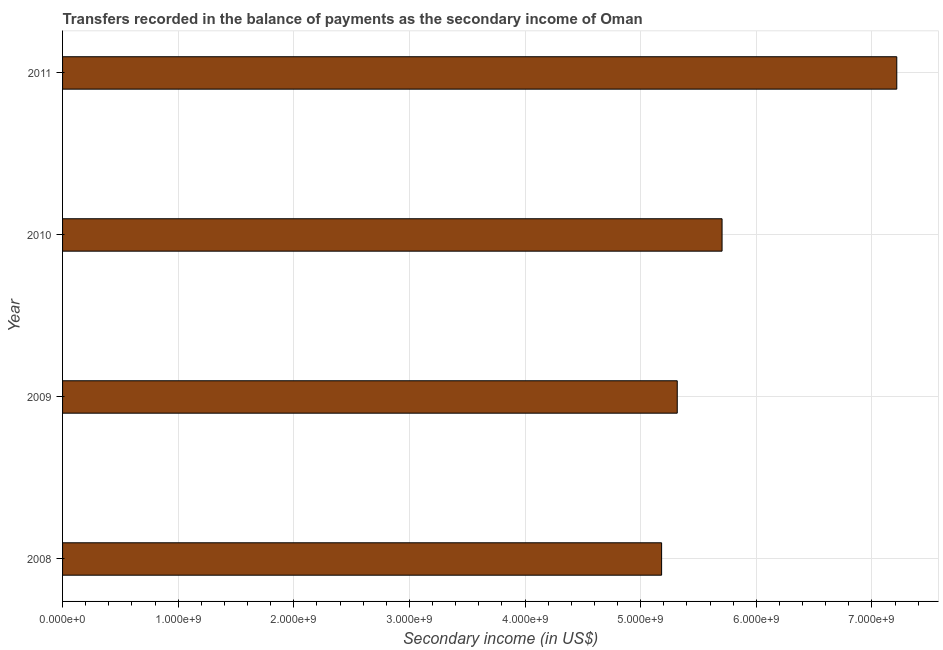Does the graph contain any zero values?
Your response must be concise. No. Does the graph contain grids?
Give a very brief answer. Yes. What is the title of the graph?
Your response must be concise. Transfers recorded in the balance of payments as the secondary income of Oman. What is the label or title of the X-axis?
Your response must be concise. Secondary income (in US$). What is the label or title of the Y-axis?
Offer a very short reply. Year. What is the amount of secondary income in 2010?
Your answer should be very brief. 5.70e+09. Across all years, what is the maximum amount of secondary income?
Provide a short and direct response. 7.21e+09. Across all years, what is the minimum amount of secondary income?
Ensure brevity in your answer.  5.18e+09. What is the sum of the amount of secondary income?
Your answer should be compact. 2.34e+1. What is the difference between the amount of secondary income in 2009 and 2011?
Offer a terse response. -1.90e+09. What is the average amount of secondary income per year?
Offer a terse response. 5.85e+09. What is the median amount of secondary income?
Your answer should be very brief. 5.51e+09. In how many years, is the amount of secondary income greater than 4800000000 US$?
Your response must be concise. 4. What is the ratio of the amount of secondary income in 2009 to that in 2010?
Ensure brevity in your answer.  0.93. What is the difference between the highest and the second highest amount of secondary income?
Your answer should be very brief. 1.51e+09. Is the sum of the amount of secondary income in 2009 and 2010 greater than the maximum amount of secondary income across all years?
Provide a short and direct response. Yes. What is the difference between the highest and the lowest amount of secondary income?
Offer a terse response. 2.03e+09. In how many years, is the amount of secondary income greater than the average amount of secondary income taken over all years?
Ensure brevity in your answer.  1. How many bars are there?
Your answer should be very brief. 4. How many years are there in the graph?
Your answer should be very brief. 4. Are the values on the major ticks of X-axis written in scientific E-notation?
Provide a succinct answer. Yes. What is the Secondary income (in US$) in 2008?
Your answer should be compact. 5.18e+09. What is the Secondary income (in US$) in 2009?
Offer a terse response. 5.32e+09. What is the Secondary income (in US$) of 2010?
Your answer should be very brief. 5.70e+09. What is the Secondary income (in US$) of 2011?
Make the answer very short. 7.21e+09. What is the difference between the Secondary income (in US$) in 2008 and 2009?
Offer a very short reply. -1.35e+08. What is the difference between the Secondary income (in US$) in 2008 and 2010?
Keep it short and to the point. -5.23e+08. What is the difference between the Secondary income (in US$) in 2008 and 2011?
Offer a terse response. -2.03e+09. What is the difference between the Secondary income (in US$) in 2009 and 2010?
Your answer should be very brief. -3.88e+08. What is the difference between the Secondary income (in US$) in 2009 and 2011?
Give a very brief answer. -1.90e+09. What is the difference between the Secondary income (in US$) in 2010 and 2011?
Your response must be concise. -1.51e+09. What is the ratio of the Secondary income (in US$) in 2008 to that in 2010?
Your answer should be compact. 0.91. What is the ratio of the Secondary income (in US$) in 2008 to that in 2011?
Make the answer very short. 0.72. What is the ratio of the Secondary income (in US$) in 2009 to that in 2010?
Offer a very short reply. 0.93. What is the ratio of the Secondary income (in US$) in 2009 to that in 2011?
Keep it short and to the point. 0.74. What is the ratio of the Secondary income (in US$) in 2010 to that in 2011?
Keep it short and to the point. 0.79. 